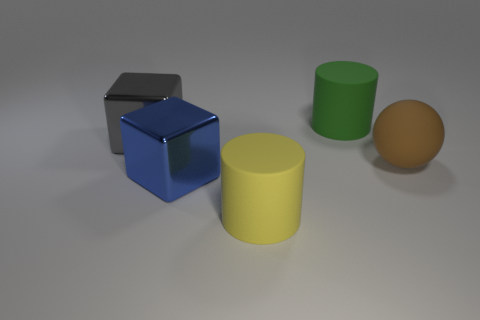There is a ball that is in front of the shiny object that is behind the blue metallic block; what is its material?
Keep it short and to the point. Rubber. Are there any blocks that have the same material as the big blue thing?
Offer a very short reply. Yes. The matte thing to the right of the matte cylinder that is to the right of the cylinder in front of the big blue thing is what shape?
Give a very brief answer. Sphere. What is the material of the large gray block?
Provide a succinct answer. Metal. The large cube that is the same material as the gray thing is what color?
Offer a very short reply. Blue. Is there a big gray cube that is to the left of the big cylinder that is in front of the large ball?
Offer a terse response. Yes. How many other objects are the same shape as the yellow matte thing?
Offer a very short reply. 1. Do the shiny thing in front of the brown rubber thing and the big rubber object that is behind the gray shiny cube have the same shape?
Keep it short and to the point. No. How many big metal objects are right of the cylinder in front of the large cylinder behind the large ball?
Give a very brief answer. 0. What color is the rubber sphere?
Offer a very short reply. Brown. 